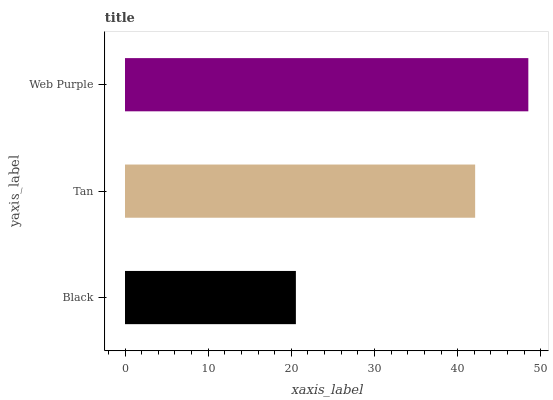Is Black the minimum?
Answer yes or no. Yes. Is Web Purple the maximum?
Answer yes or no. Yes. Is Tan the minimum?
Answer yes or no. No. Is Tan the maximum?
Answer yes or no. No. Is Tan greater than Black?
Answer yes or no. Yes. Is Black less than Tan?
Answer yes or no. Yes. Is Black greater than Tan?
Answer yes or no. No. Is Tan less than Black?
Answer yes or no. No. Is Tan the high median?
Answer yes or no. Yes. Is Tan the low median?
Answer yes or no. Yes. Is Web Purple the high median?
Answer yes or no. No. Is Web Purple the low median?
Answer yes or no. No. 